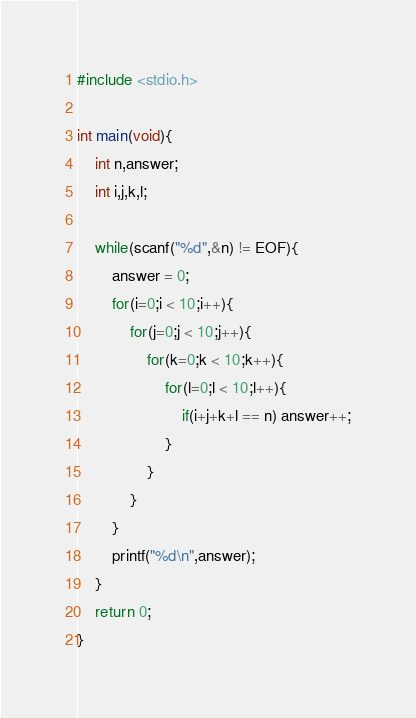Convert code to text. <code><loc_0><loc_0><loc_500><loc_500><_C_>#include <stdio.h>

int main(void){
	int n,answer;
	int i,j,k,l;
	
	while(scanf("%d",&n) != EOF){
		answer = 0;
		for(i=0;i < 10;i++){
			for(j=0;j < 10;j++){
				for(k=0;k < 10;k++){
					for(l=0;l < 10;l++){
						if(i+j+k+l == n) answer++;
					}
				}
			}
		}
		printf("%d\n",answer);
	}
	return 0;
}</code> 